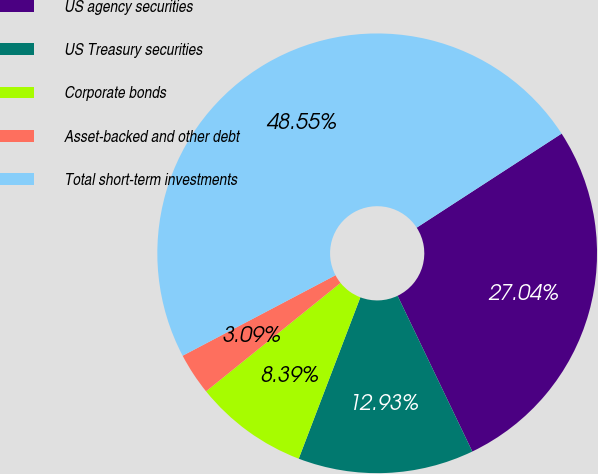Convert chart to OTSL. <chart><loc_0><loc_0><loc_500><loc_500><pie_chart><fcel>US agency securities<fcel>US Treasury securities<fcel>Corporate bonds<fcel>Asset-backed and other debt<fcel>Total short-term investments<nl><fcel>27.04%<fcel>12.93%<fcel>8.39%<fcel>3.09%<fcel>48.55%<nl></chart> 